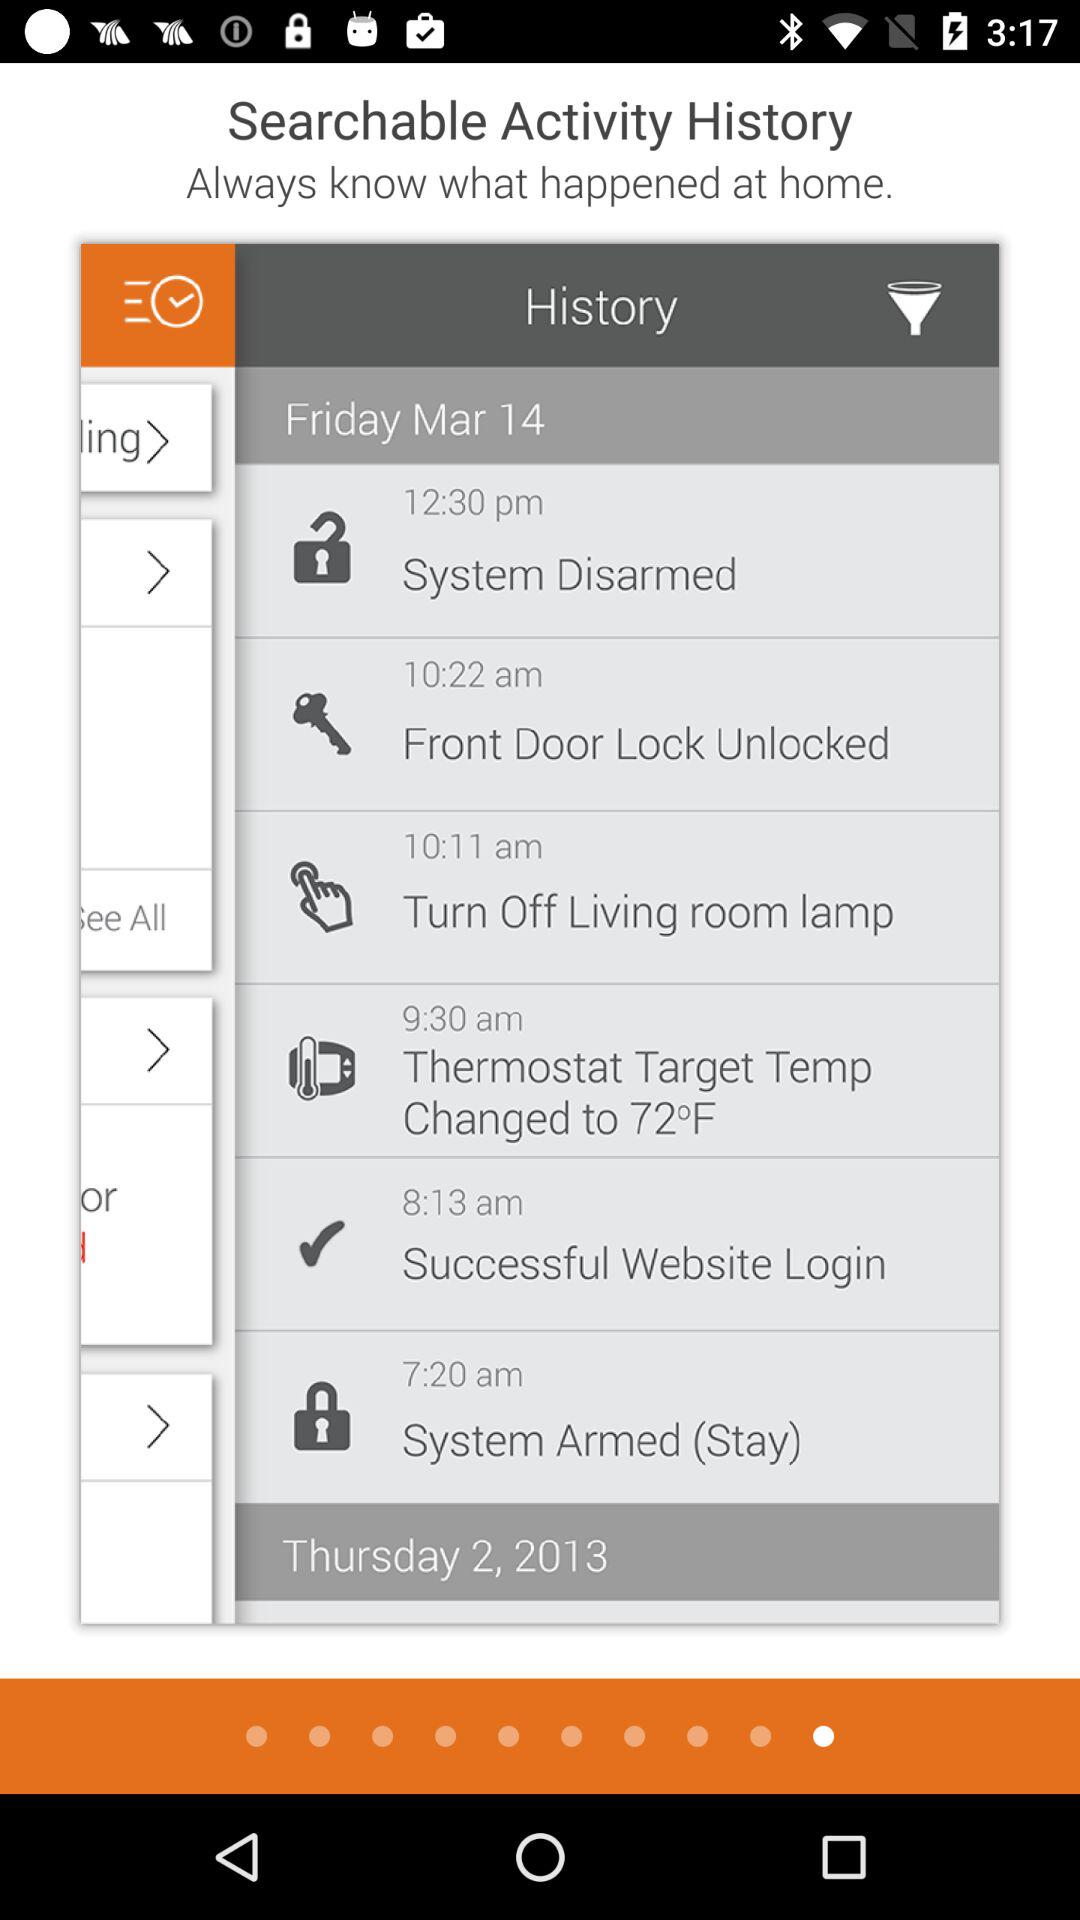What is the time of the "Successful Website Login"? The time is 8:13 a.m. 